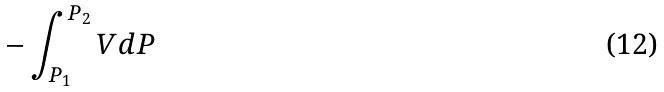Convert formula to latex. <formula><loc_0><loc_0><loc_500><loc_500>- \int _ { P _ { 1 } } ^ { P _ { 2 } } V d P</formula> 